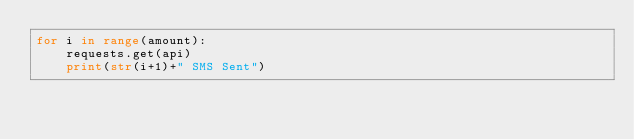Convert code to text. <code><loc_0><loc_0><loc_500><loc_500><_Python_>for i in range(amount):
	requests.get(api)
	print(str(i+1)+" SMS Sent")</code> 